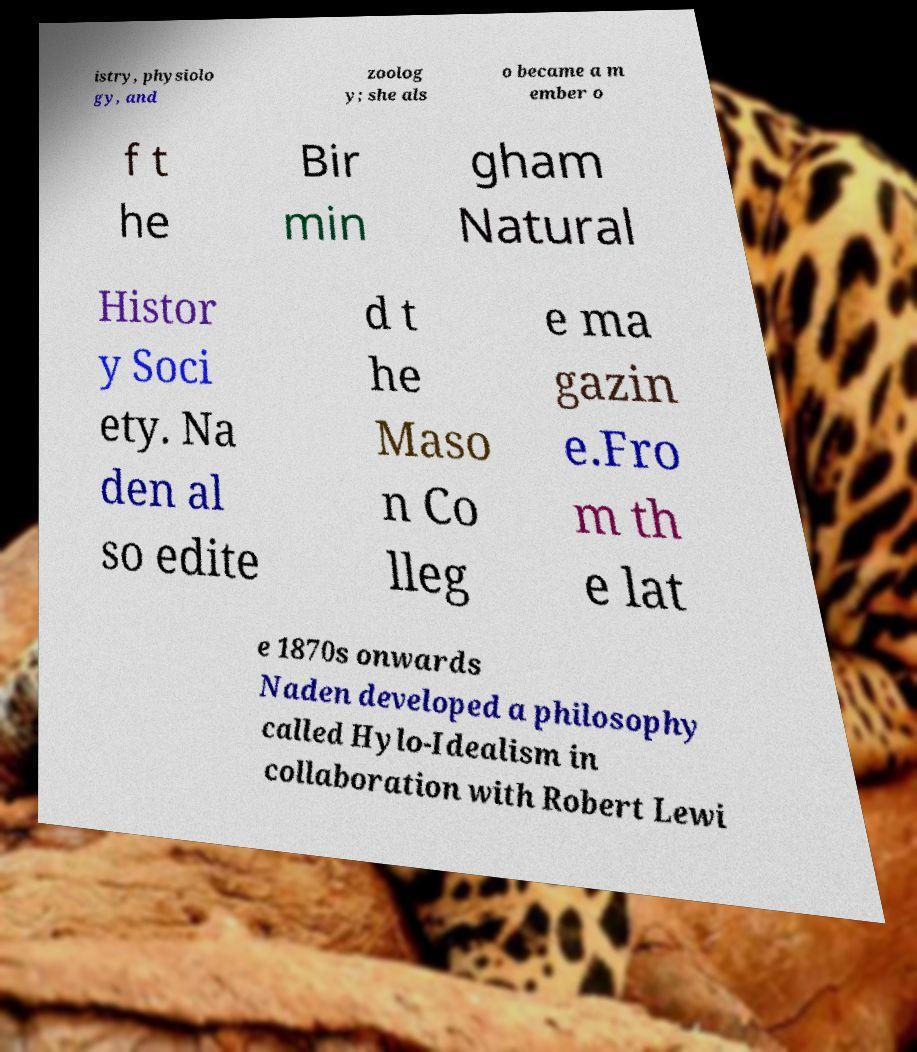I need the written content from this picture converted into text. Can you do that? istry, physiolo gy, and zoolog y; she als o became a m ember o f t he Bir min gham Natural Histor y Soci ety. Na den al so edite d t he Maso n Co lleg e ma gazin e.Fro m th e lat e 1870s onwards Naden developed a philosophy called Hylo-Idealism in collaboration with Robert Lewi 